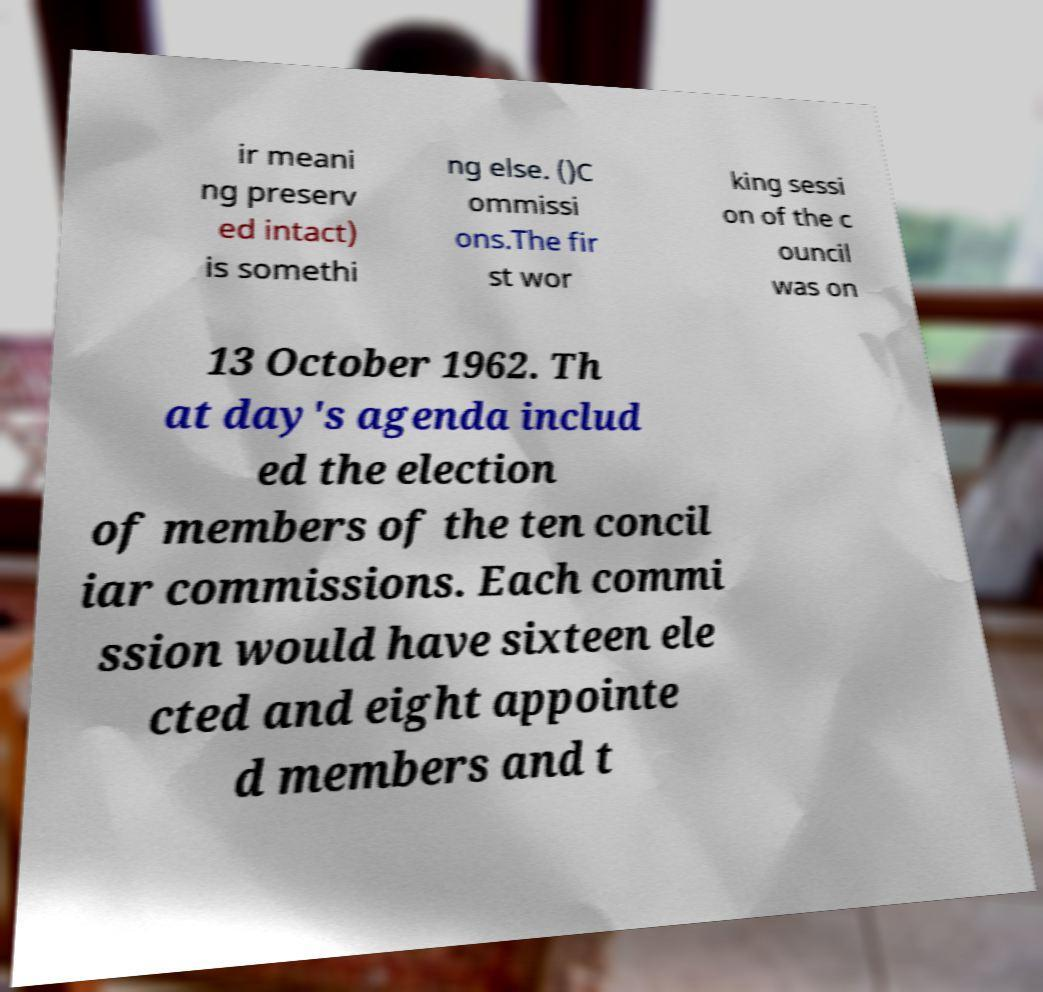Could you assist in decoding the text presented in this image and type it out clearly? ir meani ng preserv ed intact) is somethi ng else. ()C ommissi ons.The fir st wor king sessi on of the c ouncil was on 13 October 1962. Th at day's agenda includ ed the election of members of the ten concil iar commissions. Each commi ssion would have sixteen ele cted and eight appointe d members and t 